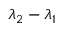<formula> <loc_0><loc_0><loc_500><loc_500>\lambda _ { 2 } - \lambda _ { 1 }</formula> 